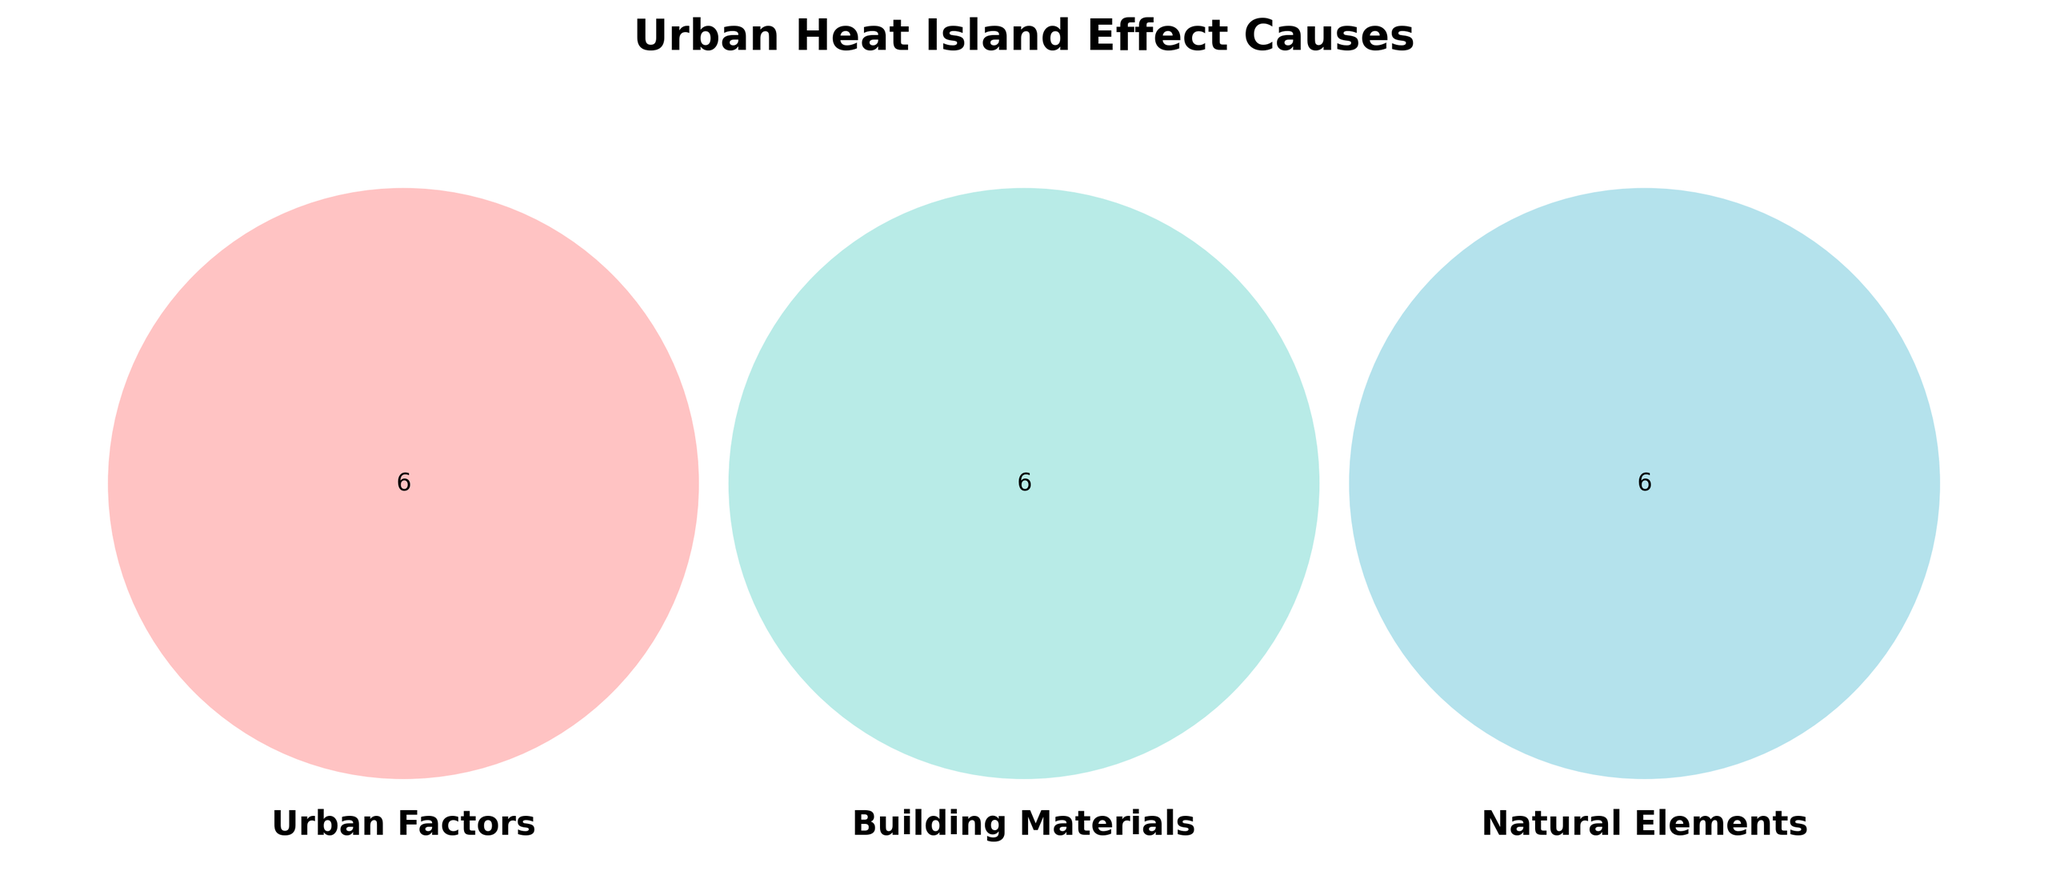What is the title of the Venn Diagram? The title of the Venn Diagram is displayed at the top of the figure. It provides information about the overall topic of the diagram.
Answer: Urban Heat Island Effect Causes Which section represents only Urban Factors? The section labeled with only one circle in red labeled 'Urban Factors' contains elements like Asphalt, High-rise buildings, Dense traffic, Reduced airflow, Air conditioning, and Industrial activities.
Answer: Urban Factors What are the overlapping elements between Urban Factors and Building Materials? Overlapping elements between Urban Factors and Building Materials are located in the section where the red and green circles intersect.
Answer: None Which overlapping area is the smallest in terms of the number of elements? By examining the intersections between circles, the smallest overlapping area can be identified based on the number of elements. The intersection between Urban Factors, Building Materials, and Natural Elements has the smallest number with zero elements.
Answer: Intersection of all three sets How many elements are common between Natural Elements and Building Materials? The section where the blue and green circles overlap displays elements that are shared between Natural Elements and Building Materials.
Answer: None Which category contains elements such as Vegetation, Water bodies, Green spaces, Parks, and Trees? By referring to the titles and corresponding elements within each section, these elements are specific to the 'Natural Elements' category highlighted in blue.
Answer: Natural Elements List the elements that fall exclusively under Building Materials. The elements exclusively under Building Materials are found within the green circle labeled 'Building Materials' with no overlapping sections.
Answer: Concrete, Metal roofing, Glass facades, Dark surfaces, Heat-absorbing materials, Lack of shade Are there any elements that overlap between Urban Factors and Natural Elements only? The section where the red and blue circles overlap without inclusion in the green circle indicates elements shared only between Urban Factors and Natural Elements.
Answer: None What color represents the Urban Factors section? The Urban Factors section is depicted by a circle with a specific color distinct from others, which is red.
Answer: Red 